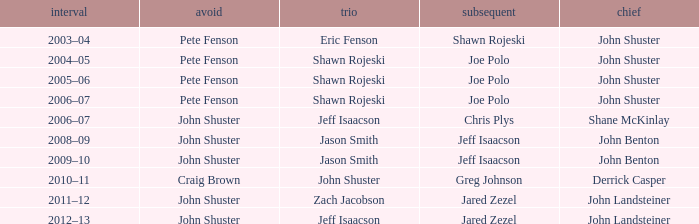Who was second when Shane McKinlay was the lead? Chris Plys. 